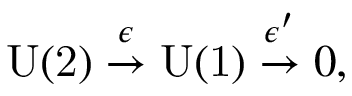Convert formula to latex. <formula><loc_0><loc_0><loc_500><loc_500>U ( 2 ) \stackrel { \epsilon } \rightarrow U ( 1 ) \stackrel { \epsilon ^ { \prime } } \rightarrow 0 ,</formula> 